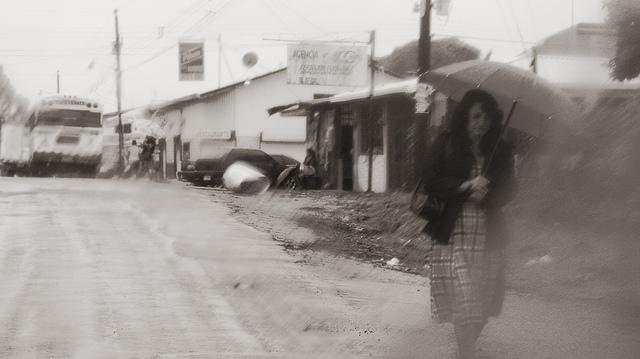Is this a black and white picture?
Keep it brief. Yes. Is this photo blurry?
Be succinct. Yes. Is this in focus?
Concise answer only. No. 